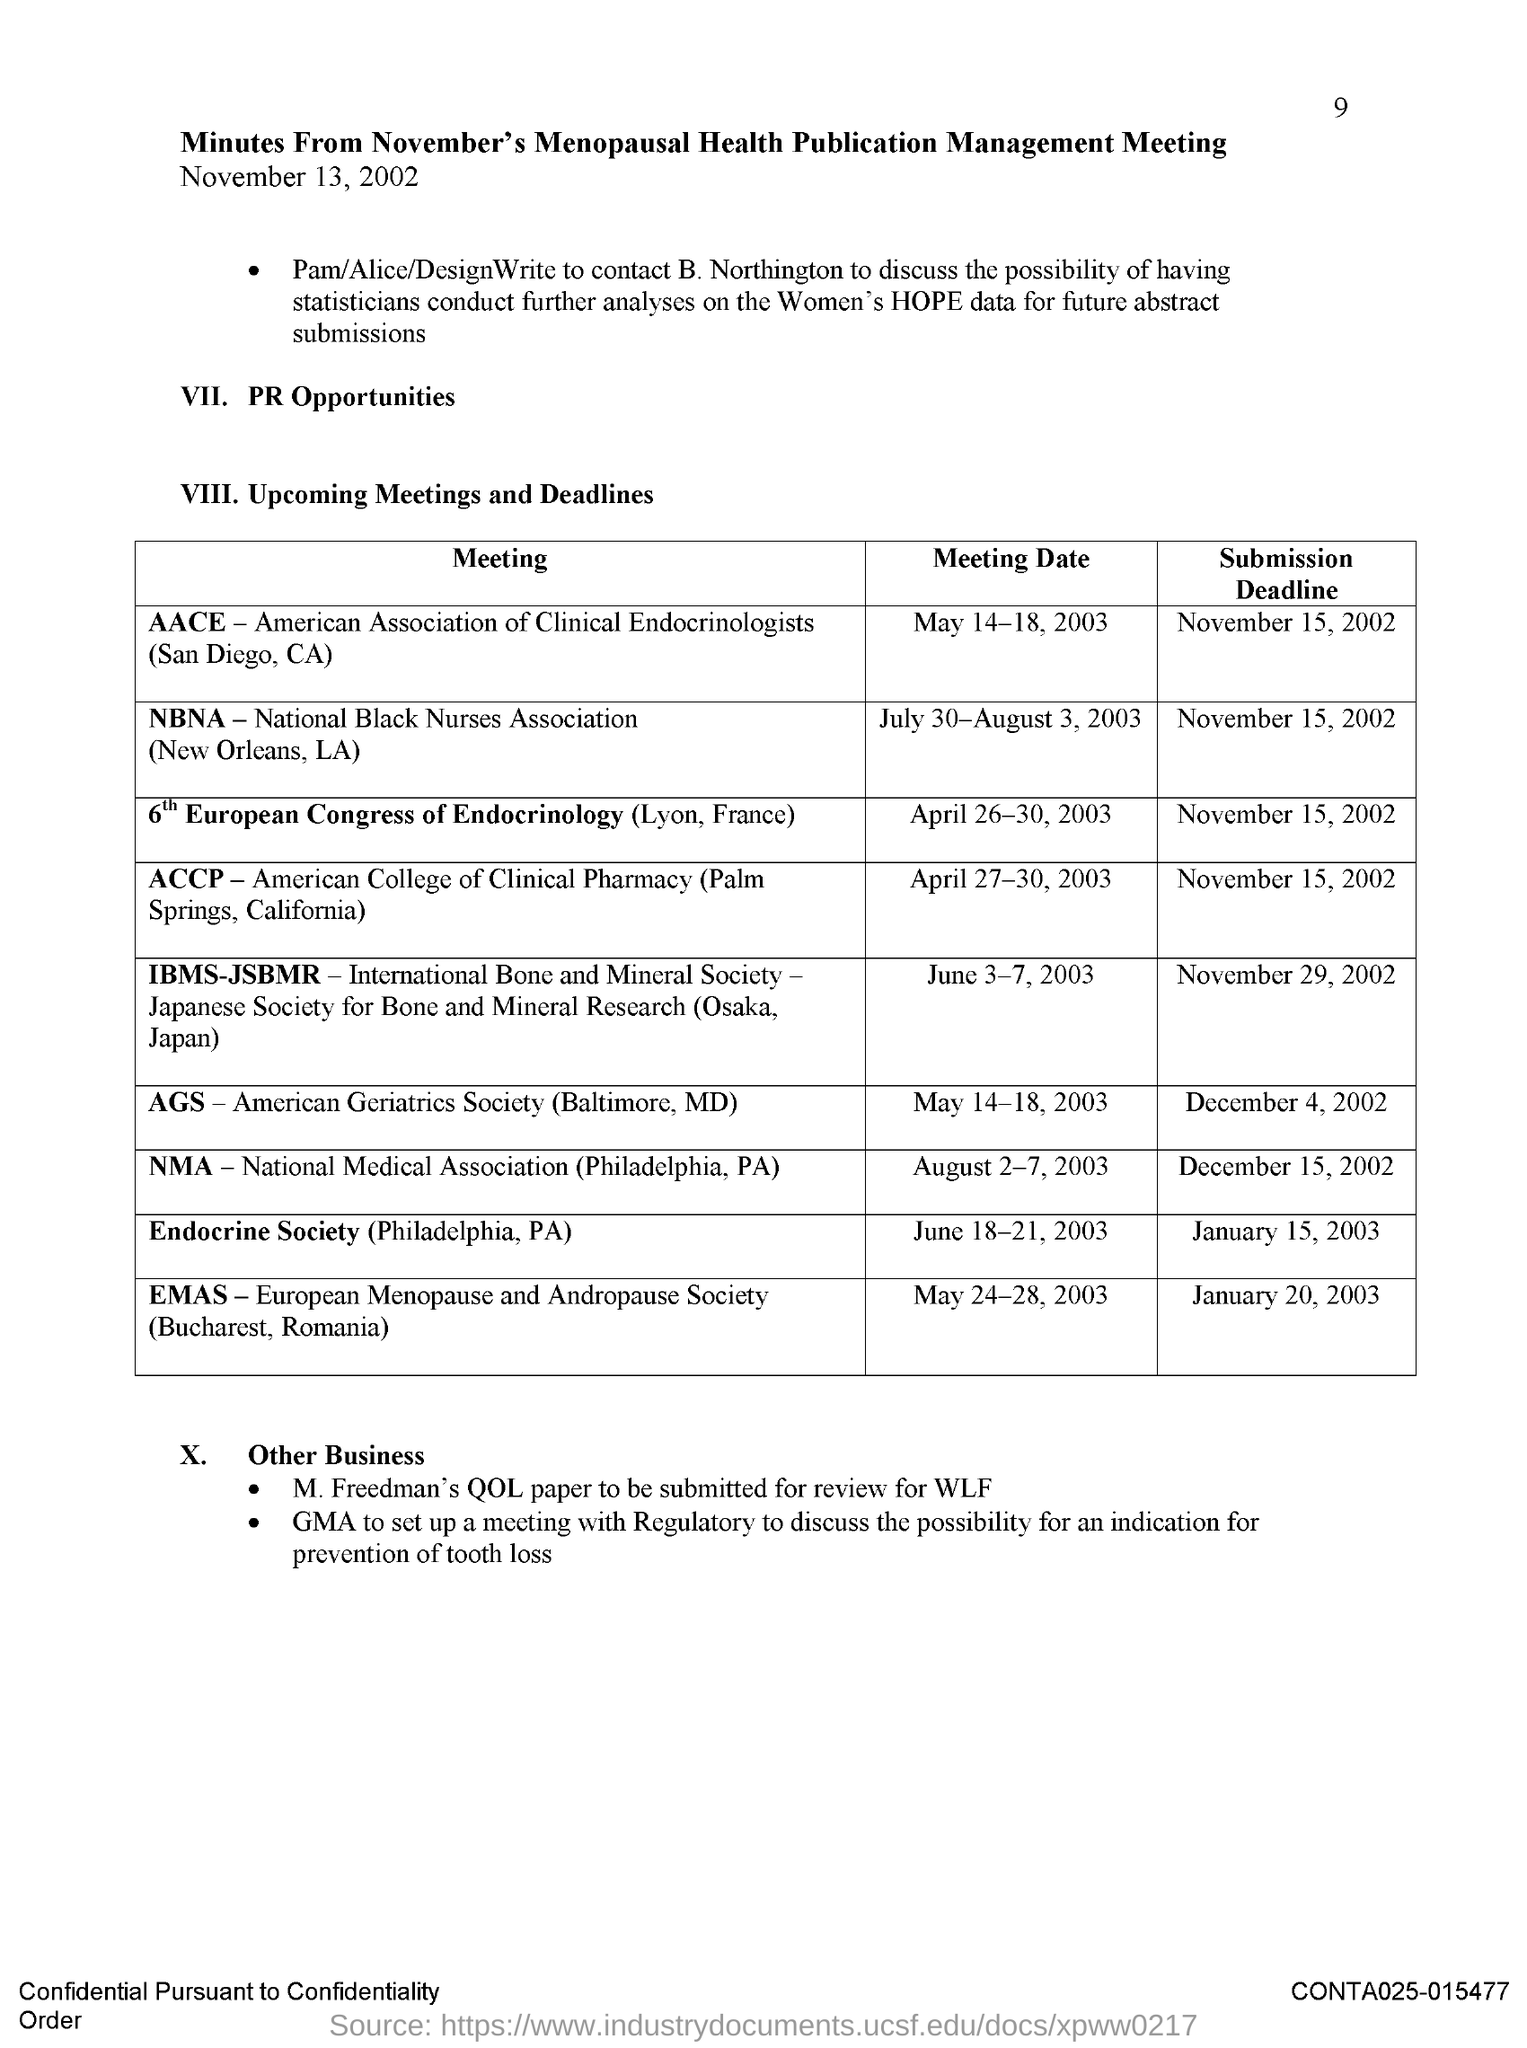What is the fullform of NBNA?
Offer a terse response. National Black Nurses Association. What is the meeting date of AACE (San Diego, CA)?
Make the answer very short. May 14-18, 2003. What is the meeting date of NBNA (New Orleans, LA)?
Keep it short and to the point. July 30-August 3, 2003. What is the submission deadline for Endocrine Society (Philadelphia, PA) meeting?
Offer a terse response. January 15, 2003. What is the submission deadline for NMA (Philadelphia, PA) meeting?
Give a very brief answer. December 15, 2002. 